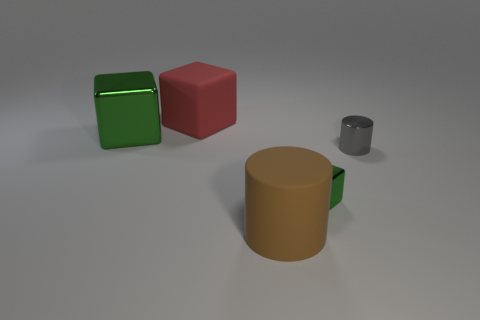Add 4 small yellow objects. How many objects exist? 9 Subtract all cylinders. How many objects are left? 3 Add 2 small green blocks. How many small green blocks are left? 3 Add 3 red blocks. How many red blocks exist? 4 Subtract 1 red cubes. How many objects are left? 4 Subtract all tiny cubes. Subtract all big blocks. How many objects are left? 2 